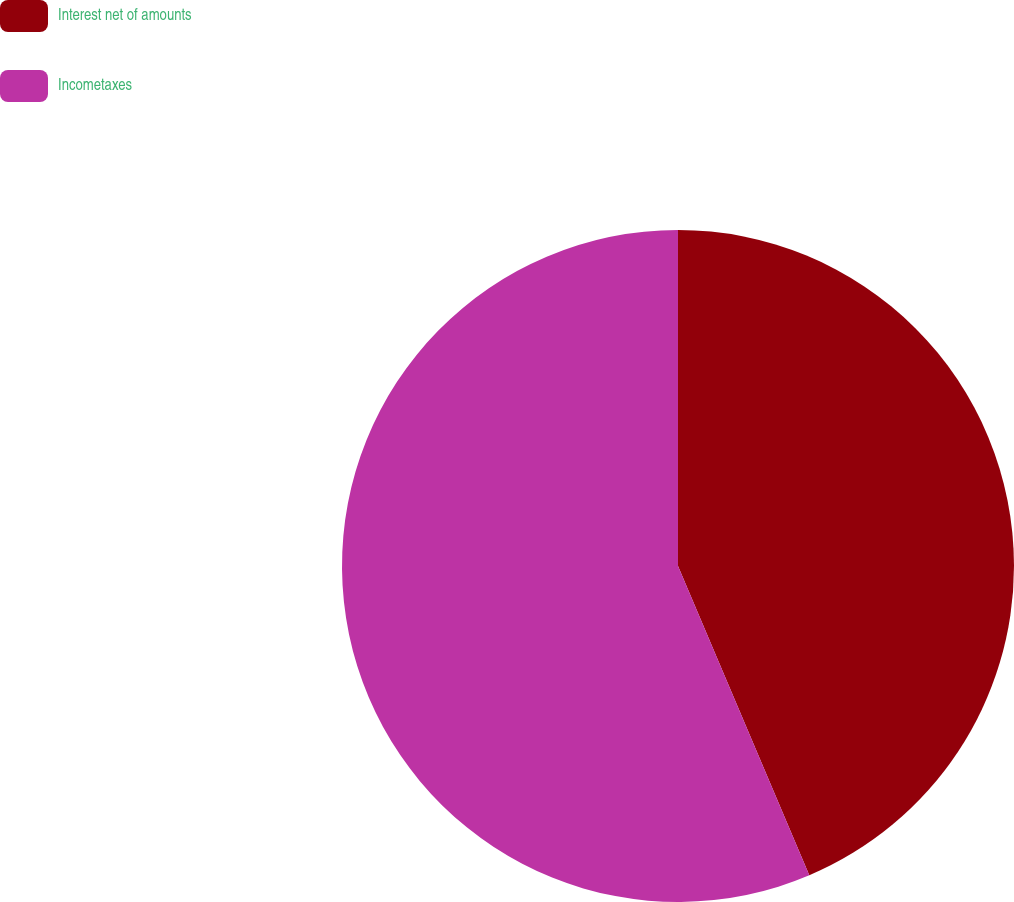Convert chart to OTSL. <chart><loc_0><loc_0><loc_500><loc_500><pie_chart><fcel>Interest net of amounts<fcel>Incometaxes<nl><fcel>43.61%<fcel>56.39%<nl></chart> 